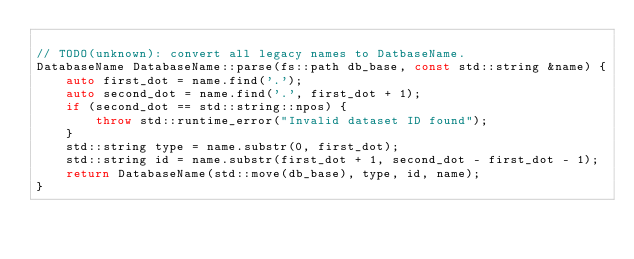<code> <loc_0><loc_0><loc_500><loc_500><_C++_>
// TODO(unknown): convert all legacy names to DatbaseName.
DatabaseName DatabaseName::parse(fs::path db_base, const std::string &name) {
    auto first_dot = name.find('.');
    auto second_dot = name.find('.', first_dot + 1);
    if (second_dot == std::string::npos) {
        throw std::runtime_error("Invalid dataset ID found");
    }
    std::string type = name.substr(0, first_dot);
    std::string id = name.substr(first_dot + 1, second_dot - first_dot - 1);
    return DatabaseName(std::move(db_base), type, id, name);
}
</code> 